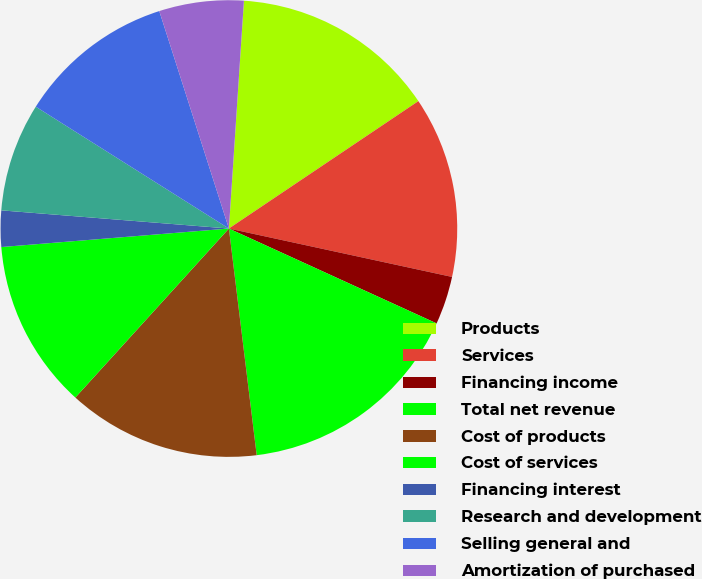<chart> <loc_0><loc_0><loc_500><loc_500><pie_chart><fcel>Products<fcel>Services<fcel>Financing income<fcel>Total net revenue<fcel>Cost of products<fcel>Cost of services<fcel>Financing interest<fcel>Research and development<fcel>Selling general and<fcel>Amortization of purchased<nl><fcel>14.53%<fcel>12.82%<fcel>3.42%<fcel>16.24%<fcel>13.68%<fcel>11.97%<fcel>2.56%<fcel>7.69%<fcel>11.11%<fcel>5.98%<nl></chart> 